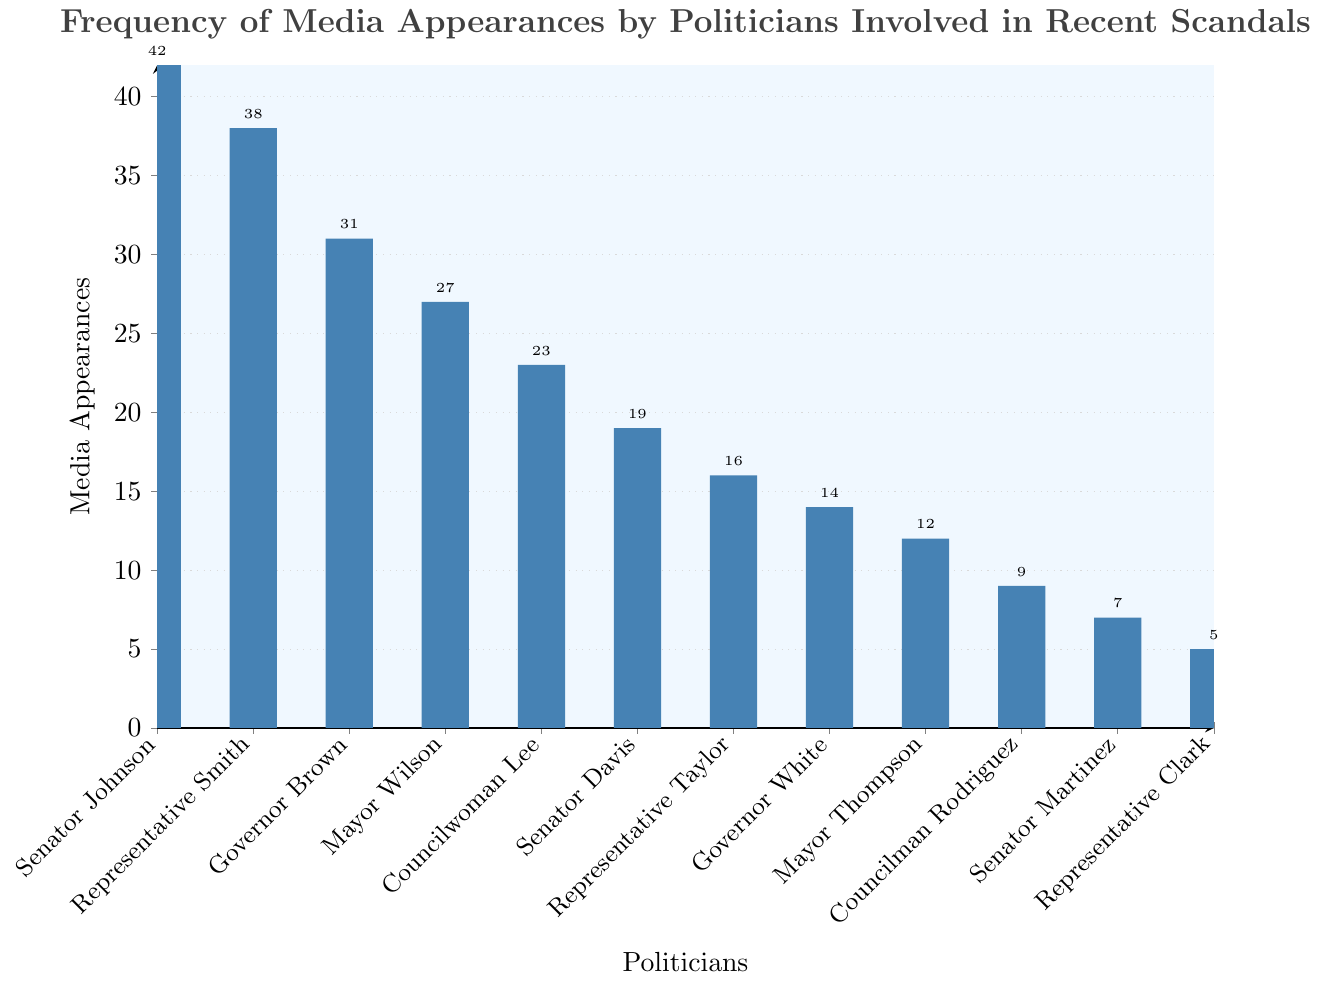Which politician has the highest number of media appearances? By examining the height of the bars on the chart, Senator Johnson has the tallest bar, indicating the highest number of media appearances.
Answer: Senator Johnson Who has fewer media appearances, Mayor Wilson or Councilwoman Lee? By comparing the heights of their bars, Mayor Wilson has a taller bar (27 appearances) compared to Councilwoman Lee (23 appearances).
Answer: Councilwoman Lee What is the total number of media appearances for Senator Johnson and Governor Brown combined? Adding the appearances of Senator Johnson (42) and Governor Brown (31) gives: 42 + 31 = 73
Answer: 73 Which group of politicians has a median number of appearances, the top 5 or the bottom 5? Listing the media appearances for top 5 (42, 38, 31, 27, 23) and bottom 5 (14, 12, 9, 7, 5), median for top 5 is 31 and for bottom 5 is 9.
Answer: Top 5 Is Councilman Rodriguez's bar taller or shorter than Senator Martinez's bar? Comparing their bars, Councilman Rodriguez has a taller bar (9) compared to Senator Martinez’s bar (7).
Answer: Taller Which politician has just under half the media appearances of Senator Johnson? Senator Johnson has 42 appearances, half of which is 21. Governor White has 14 appearances, which is the closest to half (but under) Johnson’s appearances.
Answer: Governor White List the politicians with more than 20 media appearances. Identifying bars taller than 20: Senator Johnson, Representative Smith, Governor Brown, Mayor Wilson, and Councilwoman Lee all have more than 20 appearances.
Answer: Senator Johnson, Representative Smith, Governor Brown, Mayor Wilson, Councilwoman Lee How many more appearances does Representative Smith have compared to Representative Taylor? Subtracting the media appearances of Representative Taylor (16) from those of Representative Smith (38): 38 - 16 = 22
Answer: 22 What's the average media appearance of the politicians with fewer than 10 appearances? Summing up the counts: Councilman Rodriguez (9), Senator Martinez (7), Representative Clark (5): 9 + 7 + 5 = 21, then dividing by the number of politicians (3): 21/3 = 7
Answer: 7 Who has the second highest number of media appearances? By examining the sorted heights of the bars, Representative Smith has the second tallest bar (38 appearances).
Answer: Representative Smith 